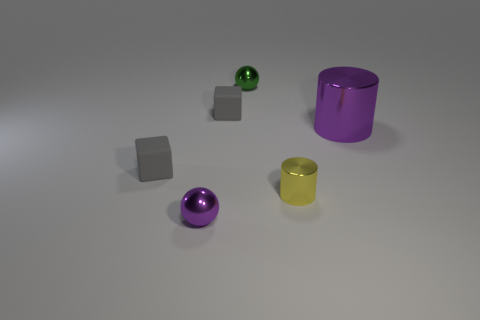Add 3 shiny balls. How many objects exist? 9 Subtract 1 cylinders. How many cylinders are left? 1 Subtract all blue blocks. How many green spheres are left? 1 Subtract all green objects. Subtract all tiny yellow things. How many objects are left? 4 Add 1 small green balls. How many small green balls are left? 2 Add 1 small rubber blocks. How many small rubber blocks exist? 3 Subtract all green spheres. How many spheres are left? 1 Subtract 1 yellow cylinders. How many objects are left? 5 Subtract all purple blocks. Subtract all red cylinders. How many blocks are left? 2 